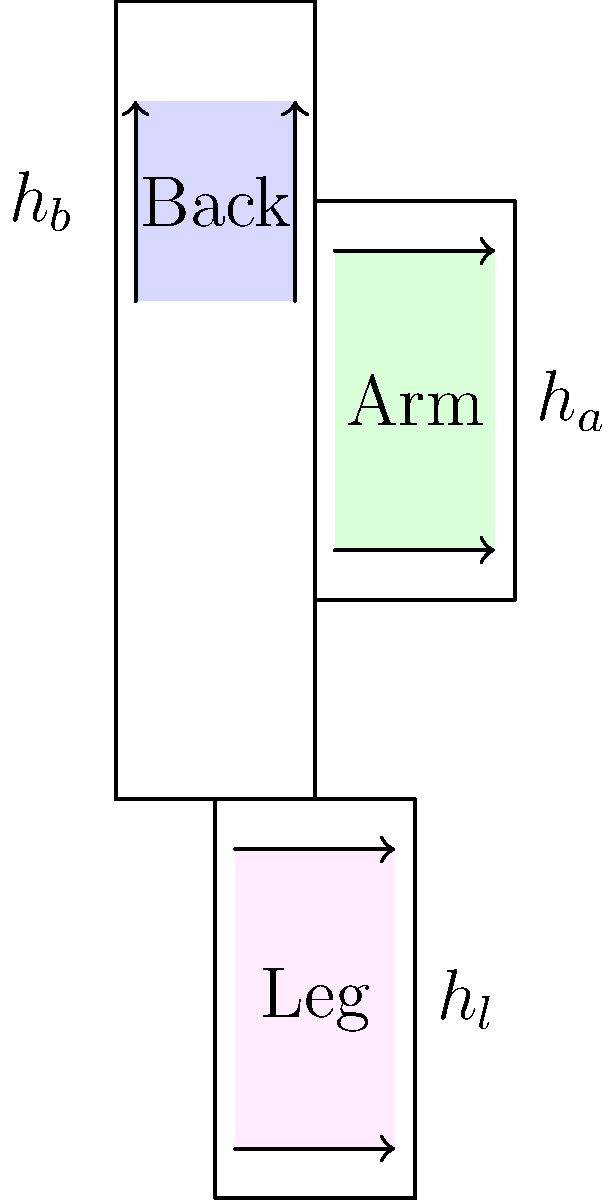A comic book enthusiast wants to get a tattoo of their favorite character on either their back, arm, or leg. Given that the character's proportions must be maintained, and the tattoo should cover the maximum area possible without distortion, which body part would allow for the largest tattoo? Assume the following measurements:

Back area: 16 cm x 20 cm
Arm area: 16 cm x 30 cm
Leg area: 16 cm x 30 cm

The character's ideal proportion is a 3:4 ratio (width:height). Calculate the maximum possible area for the tattoo on each body part and determine the optimal location. To solve this problem, we need to calculate the maximum possible area for the tattoo on each body part while maintaining the character's 3:4 ratio. Let's approach this step-by-step:

1. Back area (16 cm x 20 cm):
   - Width (w) : Height (h) = 3 : 4
   - Maximum width = 16 cm
   - Corresponding height = (16 * 4) / 3 = 21.33 cm
   - However, the available height is only 20 cm
   - So, we need to adjust: Height = 20 cm, Width = (20 * 3) / 4 = 15 cm
   - Area = 15 cm * 20 cm = 300 cm²

2. Arm area (16 cm x 30 cm):
   - Width (w) : Height (h) = 3 : 4
   - Maximum width = 16 cm
   - Corresponding height = (16 * 4) / 3 = 21.33 cm
   - This fits within the available 30 cm height
   - Area = 16 cm * 21.33 cm = 341.28 cm²

3. Leg area (16 cm x 30 cm):
   - Same dimensions as the arm area
   - Area = 16 cm * 21.33 cm = 341.28 cm²

Comparing the areas:
- Back: 300 cm²
- Arm: 341.28 cm²
- Leg: 341.28 cm²

The arm and leg allow for the largest tattoo area while maintaining the character's proportions.
Answer: Arm or leg, with a maximum area of 341.28 cm². 